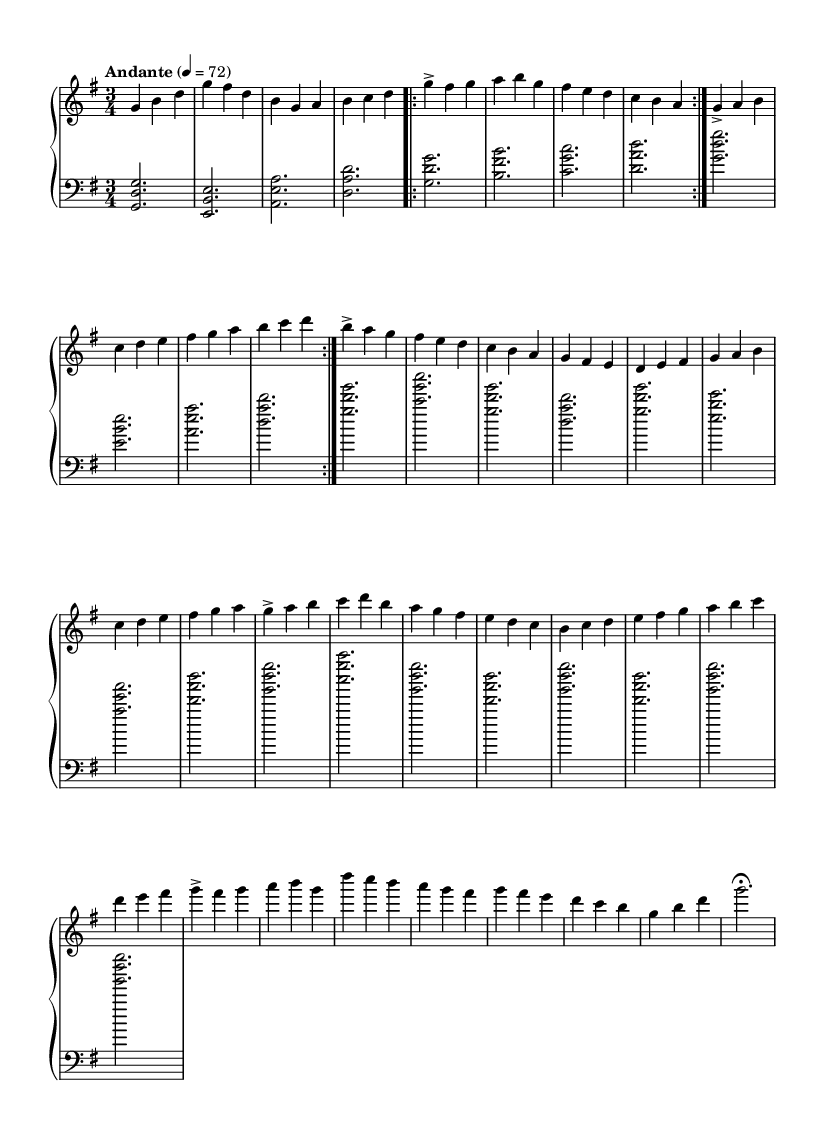What is the key signature of this music? The key signature is indicated by the sharps or flats at the beginning of the staff. In this sheet music, there is one sharp (F#), which indicates that it is in G major.
Answer: G major What is the time signature of this music? The time signature is noted at the beginning of the staff, represented by two numbers. In this case, the time signature is 3/4, which means there are three beats in each measure and the quarter note gets one beat.
Answer: 3/4 What tempo marking is indicated in this music? The tempo marking indicates the speed of the piece. It is located at the beginning of the music and is written as “Andante” followed by a metronome marking of 4 = 72, suggesting a moderate pace.
Answer: Andante How many times is Theme A repeated in this music? The repeat symbol (indicated by "Volta") shows that Theme A is played twice before moving on to Theme B. This is directly indicated in the sheet music.
Answer: 2 What is the highest note in the upper staff? By scanning the upper staff notes, the highest pitch is D, which appears in the Introduction section. The pitch D is higher than any other note present in the same section.
Answer: D What kind of musical form is represented in this piece (A-B-A)? The structure includes two themes (A and B) and then a variation of Theme A after the B section, thus illustrating an A-B-A form. This is a common form in classical music, showing the return to the initial theme after contrasting material.
Answer: A-B-A What is the dynamic marking for the introduction section? The dynamics in the introduction are indicated by the word “accent,” which suggests that these notes should be played with emphasis. This marking gives a clear instruction on how to interpret the introduction musical phrases.
Answer: Accent 